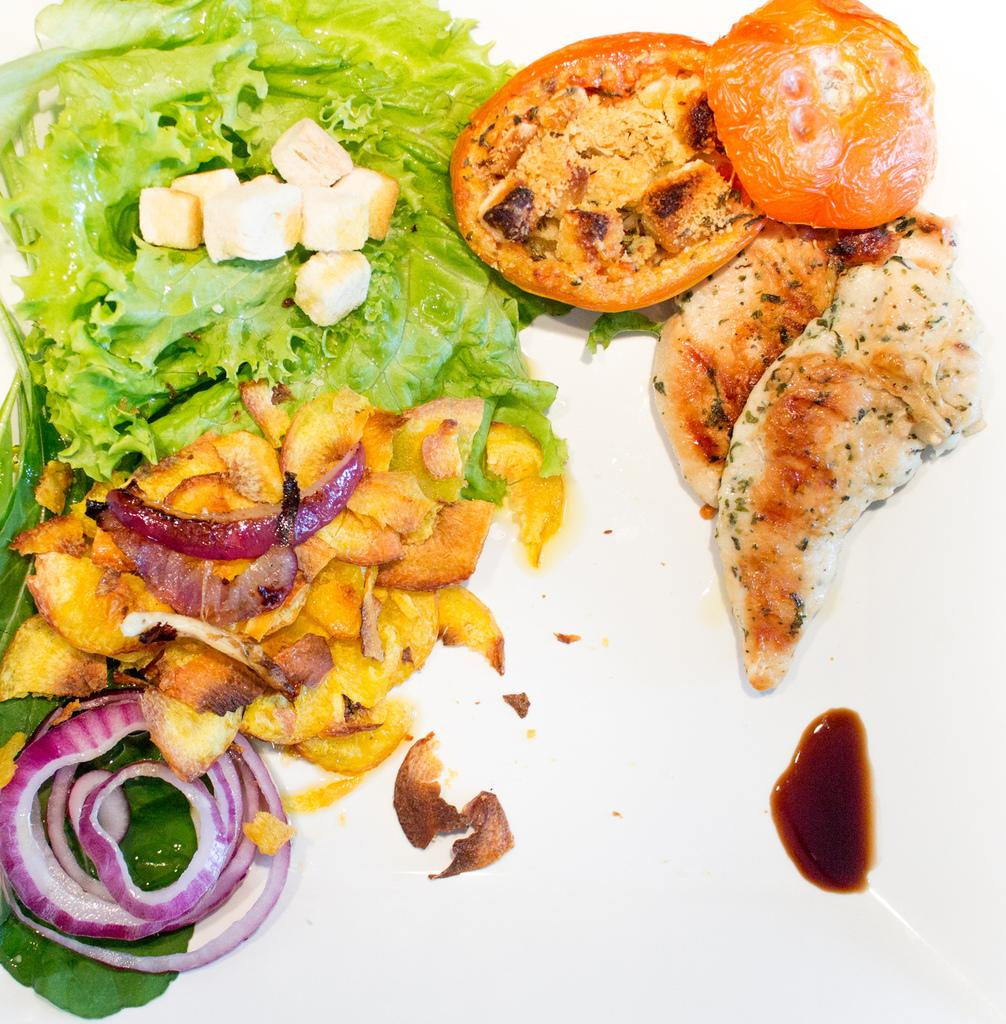What is on the plate in the image? There are food items on a plate in the image. What else can be seen on the plate besides the food items? There is sauce on the plate in the image. What type of brush is used to apply the sauce on the plate in the image? There is no brush present in the image; the sauce is already on the plate. 